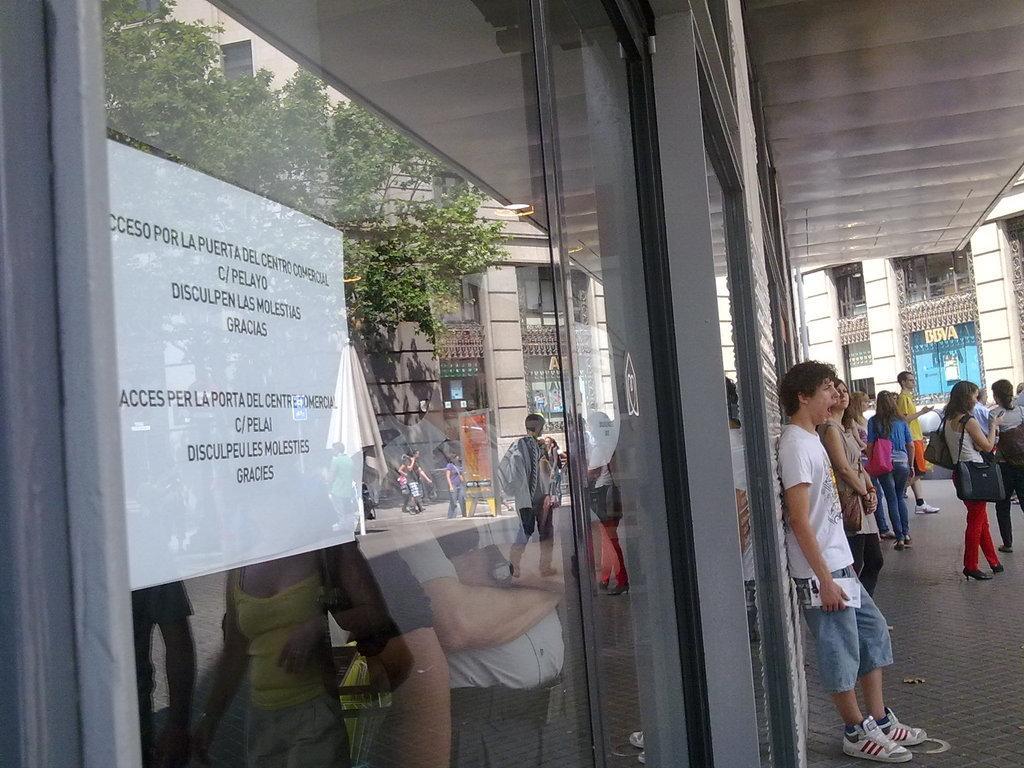Please provide a concise description of this image. In this image in the foreground there is a glass door, on which there is a notice paper attached and there is a text on the paper, on the glass there are reflections of few people, building, road, tree visible, on the right side there is a road, there are few people visible in front of building. 